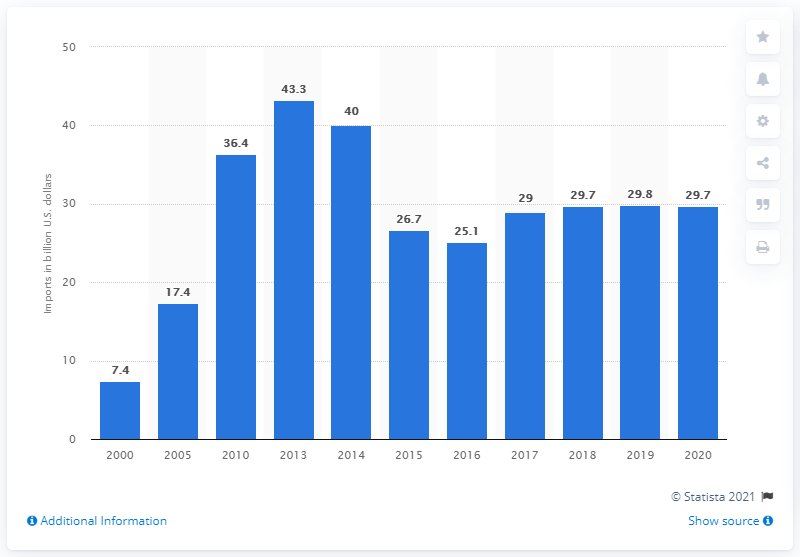Point out several critical features in this image. In 2013, the highest amount of Russian imports of foodstuffs and agricultural raw materials was 43.3 million tons. In 2020, the value of Russian imports of foodstuffs and agricultural raw materials was 29.8 billion US dollars. 